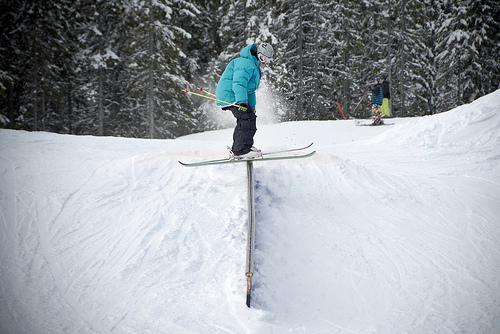Question: where was this shot?
Choices:
A. Ski resort.
B. Hospital.
C. Beach.
D. Vegas.
Answer with the letter. Answer: A Question: how many people are shown?
Choices:
A. 2.
B. 1.
C. 4.
D. 3.
Answer with the letter. Answer: D Question: what sport is shown?
Choices:
A. Golf.
B. Tennis.
C. Skiing.
D. Rugby.
Answer with the letter. Answer: C Question: what is on the person's feet?
Choices:
A. Skates.
B. Nothing.
C. Sandals.
D. Skis.
Answer with the letter. Answer: D 